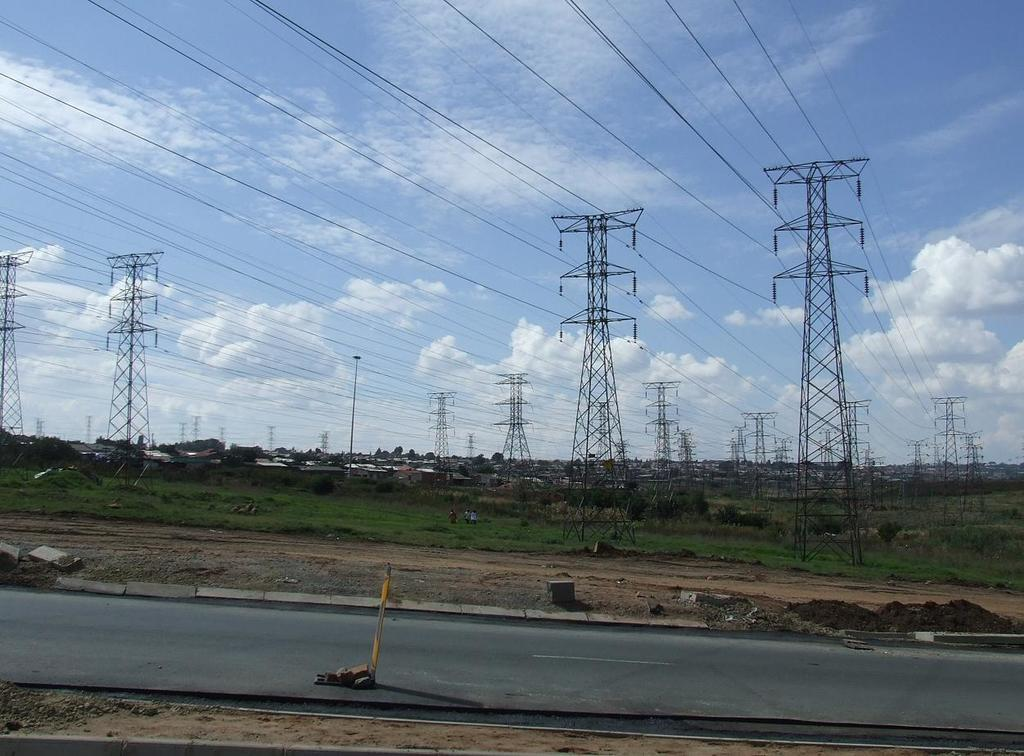What can be seen in the sky in the image? The sky with clouds is visible in the image. What structures are present in the image? Electric poles and buildings are present in the image. What are the electric poles supporting? Electric cables are present in the image, supported by the electric poles. What type of vegetation is visible in the image? Trees are visible in the image. What is the ground surface like in the image? The ground is visible in the image. What is the purpose of the road in the image? The road in the image is likely for transportation. Are there any people in the image? Yes, there are persons in the image. What type of garden can be seen in the image? There is no garden present in the image. What are the persons in the image eating for lunch? The image does not show any food or lunch, so it cannot be determined what the persons might be eating. 